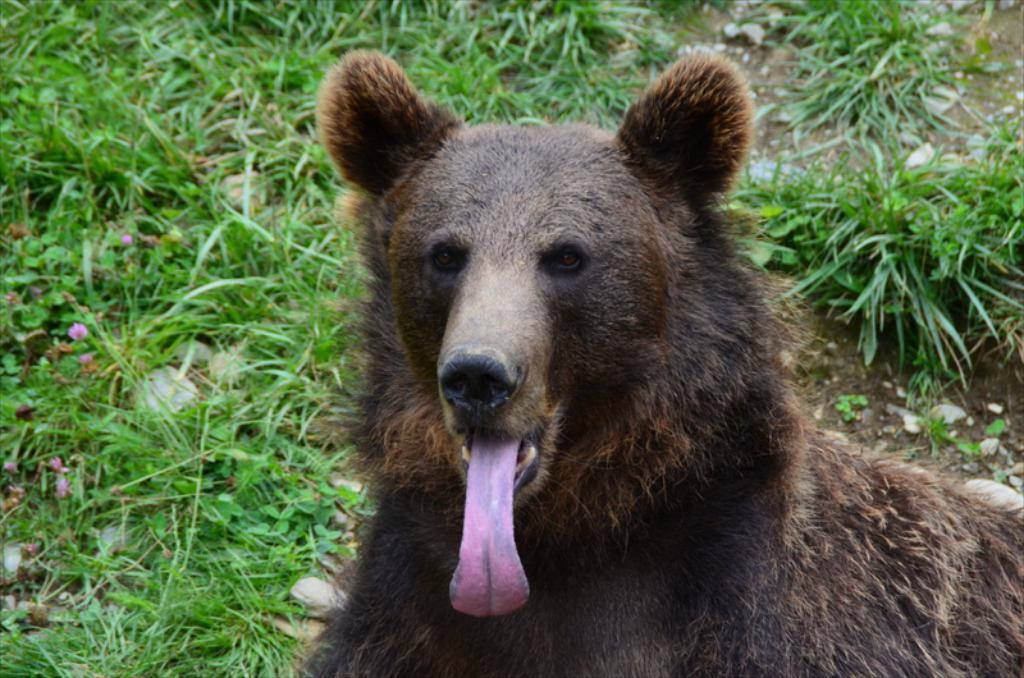What animal is the main subject of the picture? There is a black bear in the picture. What is the bear doing in the image? The bear is showing its tongue. What type of vegetation can be seen in the image? There are small flowers on the grass on the left side of the image. What color is the mist surrounding the bear in the image? There is no mist present in the image; it is a clear scene with a black bear showing its tongue and small flowers on the grass. 